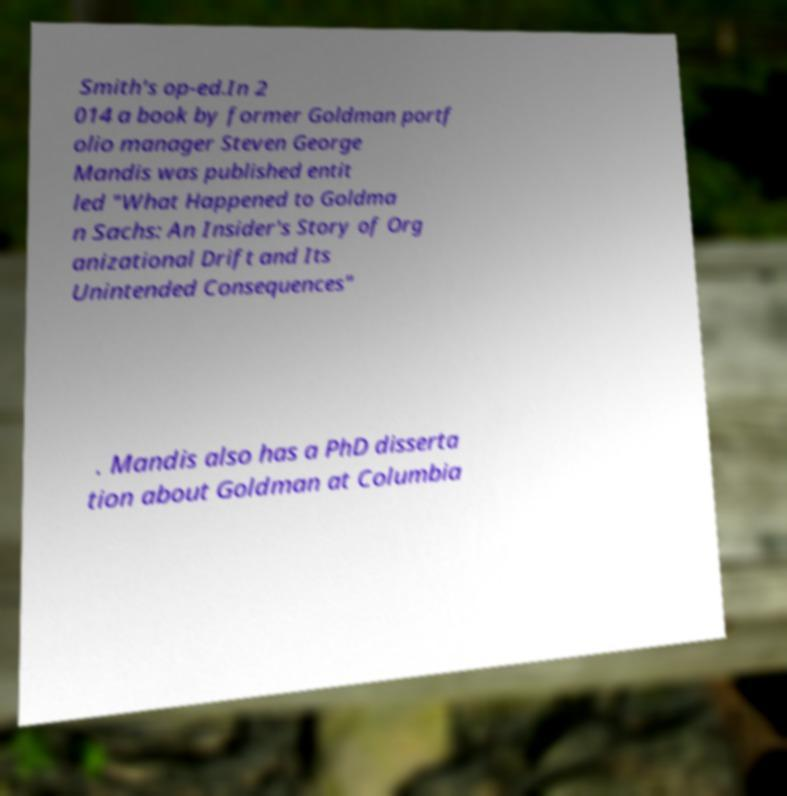I need the written content from this picture converted into text. Can you do that? Smith's op-ed.In 2 014 a book by former Goldman portf olio manager Steven George Mandis was published entit led "What Happened to Goldma n Sachs: An Insider's Story of Org anizational Drift and Its Unintended Consequences" . Mandis also has a PhD disserta tion about Goldman at Columbia 